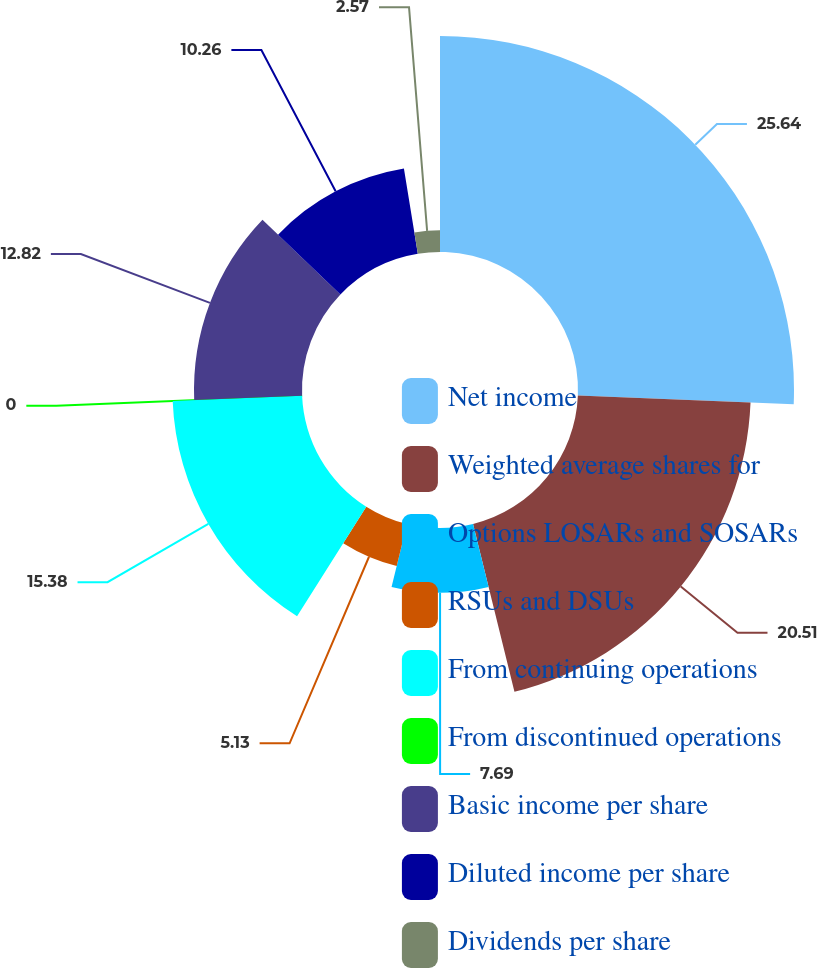<chart> <loc_0><loc_0><loc_500><loc_500><pie_chart><fcel>Net income<fcel>Weighted average shares for<fcel>Options LOSARs and SOSARs<fcel>RSUs and DSUs<fcel>From continuing operations<fcel>From discontinued operations<fcel>Basic income per share<fcel>Diluted income per share<fcel>Dividends per share<nl><fcel>25.64%<fcel>20.51%<fcel>7.69%<fcel>5.13%<fcel>15.38%<fcel>0.0%<fcel>12.82%<fcel>10.26%<fcel>2.57%<nl></chart> 